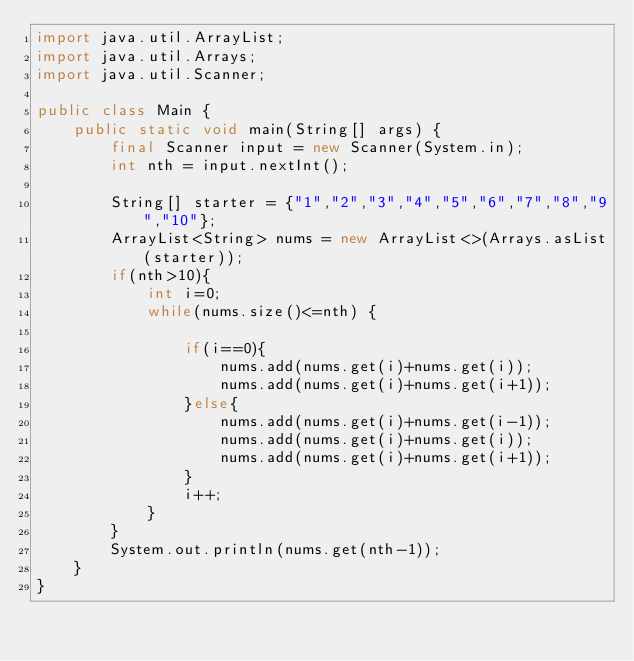<code> <loc_0><loc_0><loc_500><loc_500><_Java_>import java.util.ArrayList;
import java.util.Arrays;
import java.util.Scanner;

public class Main {
    public static void main(String[] args) {
        final Scanner input = new Scanner(System.in);
        int nth = input.nextInt();

        String[] starter = {"1","2","3","4","5","6","7","8","9","10"};
        ArrayList<String> nums = new ArrayList<>(Arrays.asList(starter));
        if(nth>10){
            int i=0;
            while(nums.size()<=nth) {

                if(i==0){
                    nums.add(nums.get(i)+nums.get(i));
                    nums.add(nums.get(i)+nums.get(i+1));
                }else{
                    nums.add(nums.get(i)+nums.get(i-1));
                    nums.add(nums.get(i)+nums.get(i));
                    nums.add(nums.get(i)+nums.get(i+1));
                }
                i++;
            }
        }
        System.out.println(nums.get(nth-1));
    }
}
</code> 